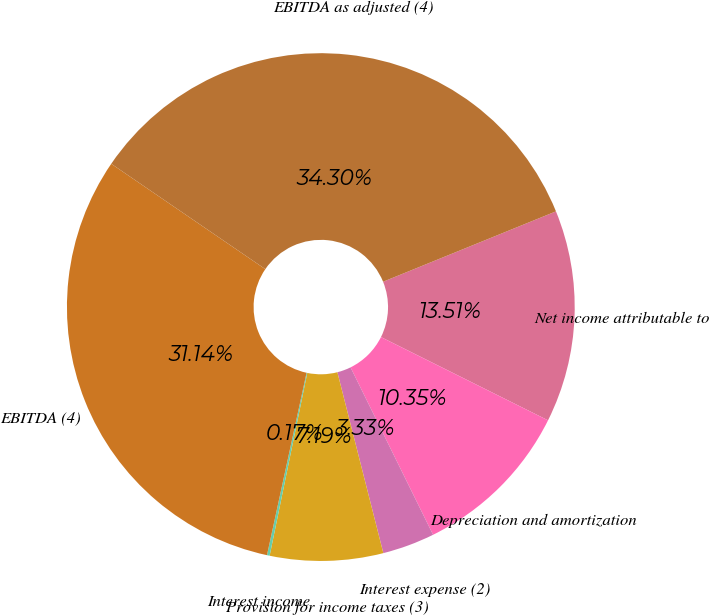<chart> <loc_0><loc_0><loc_500><loc_500><pie_chart><fcel>Net income attributable to<fcel>Depreciation and amortization<fcel>Interest expense (2)<fcel>Provision for income taxes (3)<fcel>Interest income<fcel>EBITDA (4)<fcel>EBITDA as adjusted (4)<nl><fcel>13.51%<fcel>10.35%<fcel>3.33%<fcel>7.19%<fcel>0.17%<fcel>31.14%<fcel>34.3%<nl></chart> 